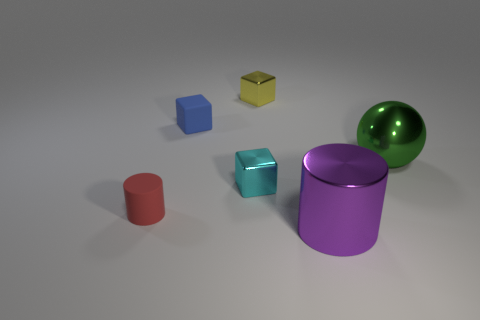Subtract all metallic cubes. How many cubes are left? 1 Add 1 green metal things. How many objects exist? 7 Subtract all cyan blocks. How many blocks are left? 2 Subtract 1 balls. How many balls are left? 0 Subtract 1 cyan blocks. How many objects are left? 5 Subtract all cylinders. How many objects are left? 4 Subtract all yellow cylinders. Subtract all blue blocks. How many cylinders are left? 2 Subtract all brown balls. How many red cylinders are left? 1 Subtract all tiny cyan cubes. Subtract all large metallic spheres. How many objects are left? 4 Add 5 purple metallic cylinders. How many purple metallic cylinders are left? 6 